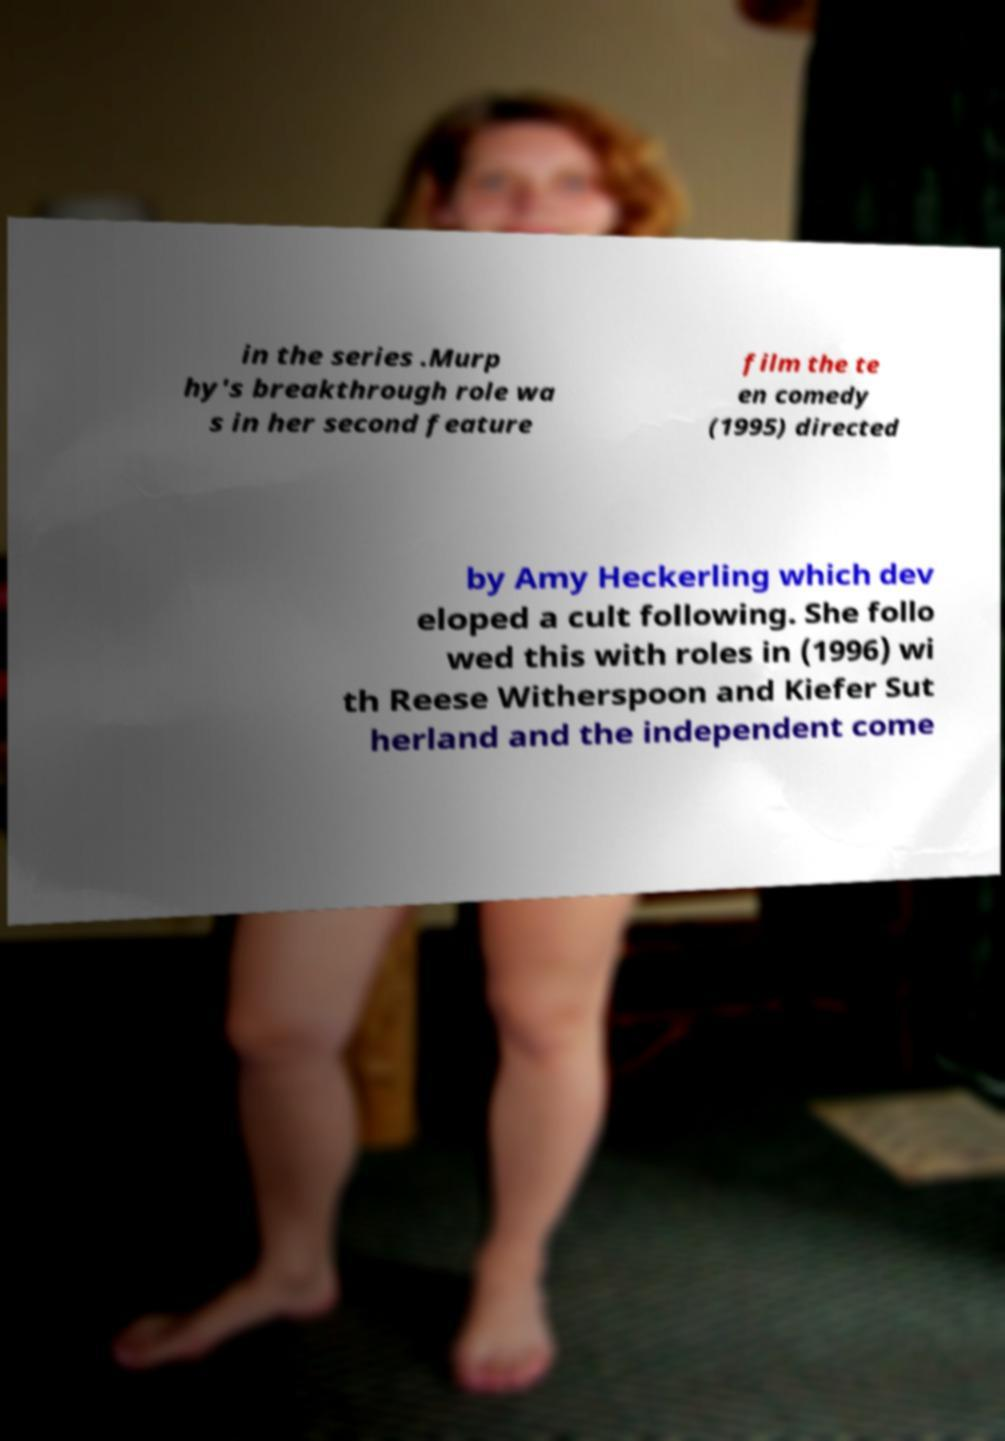What messages or text are displayed in this image? I need them in a readable, typed format. in the series .Murp hy's breakthrough role wa s in her second feature film the te en comedy (1995) directed by Amy Heckerling which dev eloped a cult following. She follo wed this with roles in (1996) wi th Reese Witherspoon and Kiefer Sut herland and the independent come 